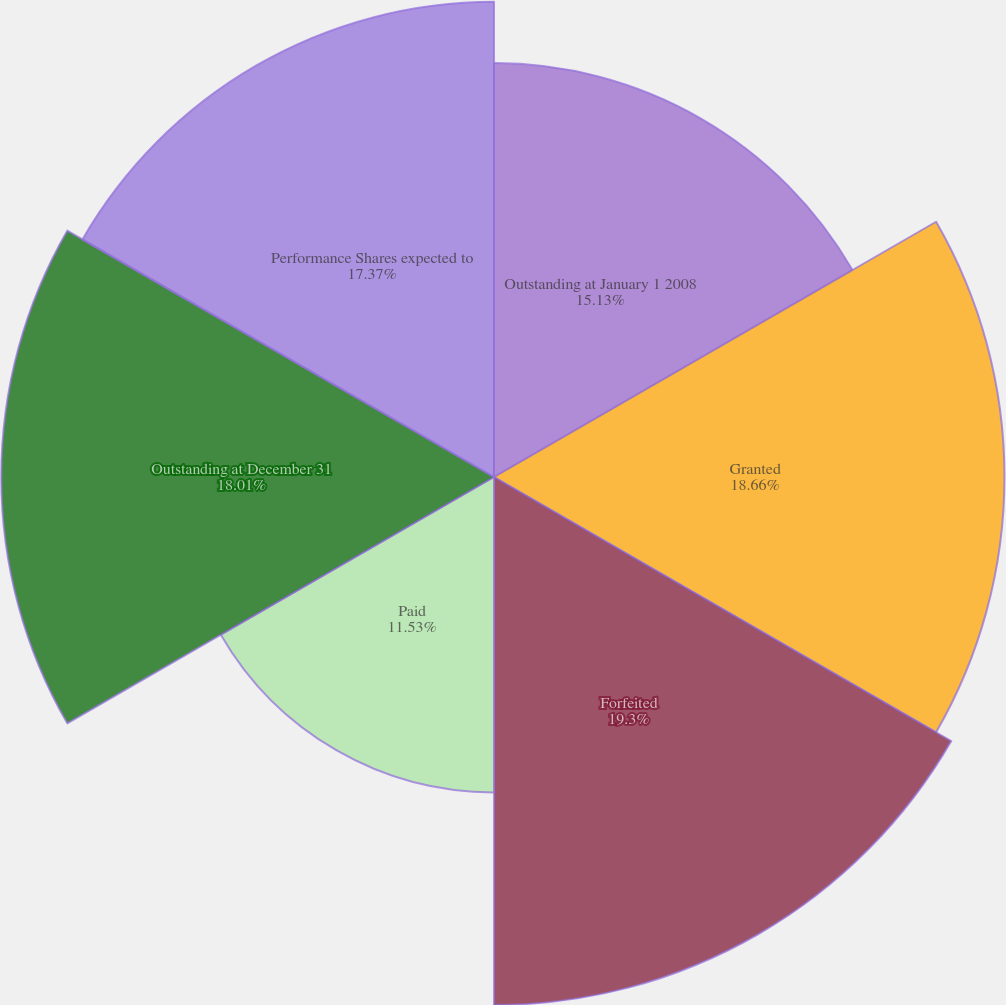Convert chart. <chart><loc_0><loc_0><loc_500><loc_500><pie_chart><fcel>Outstanding at January 1 2008<fcel>Granted<fcel>Forfeited<fcel>Paid<fcel>Outstanding at December 31<fcel>Performance Shares expected to<nl><fcel>15.13%<fcel>18.66%<fcel>19.3%<fcel>11.53%<fcel>18.01%<fcel>17.37%<nl></chart> 